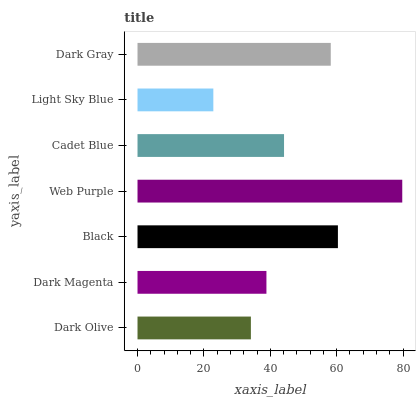Is Light Sky Blue the minimum?
Answer yes or no. Yes. Is Web Purple the maximum?
Answer yes or no. Yes. Is Dark Magenta the minimum?
Answer yes or no. No. Is Dark Magenta the maximum?
Answer yes or no. No. Is Dark Magenta greater than Dark Olive?
Answer yes or no. Yes. Is Dark Olive less than Dark Magenta?
Answer yes or no. Yes. Is Dark Olive greater than Dark Magenta?
Answer yes or no. No. Is Dark Magenta less than Dark Olive?
Answer yes or no. No. Is Cadet Blue the high median?
Answer yes or no. Yes. Is Cadet Blue the low median?
Answer yes or no. Yes. Is Dark Magenta the high median?
Answer yes or no. No. Is Dark Magenta the low median?
Answer yes or no. No. 